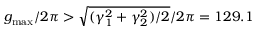<formula> <loc_0><loc_0><loc_500><loc_500>g _ { \max } / 2 \pi > \sqrt { ( \gamma _ { 1 } ^ { 2 } + \gamma _ { 2 } ^ { 2 } ) / 2 } / 2 \pi = 1 2 9 . 1</formula> 